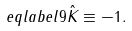Convert formula to latex. <formula><loc_0><loc_0><loc_500><loc_500>\ e q l a b e l { 9 } \hat { K } \equiv - 1 .</formula> 